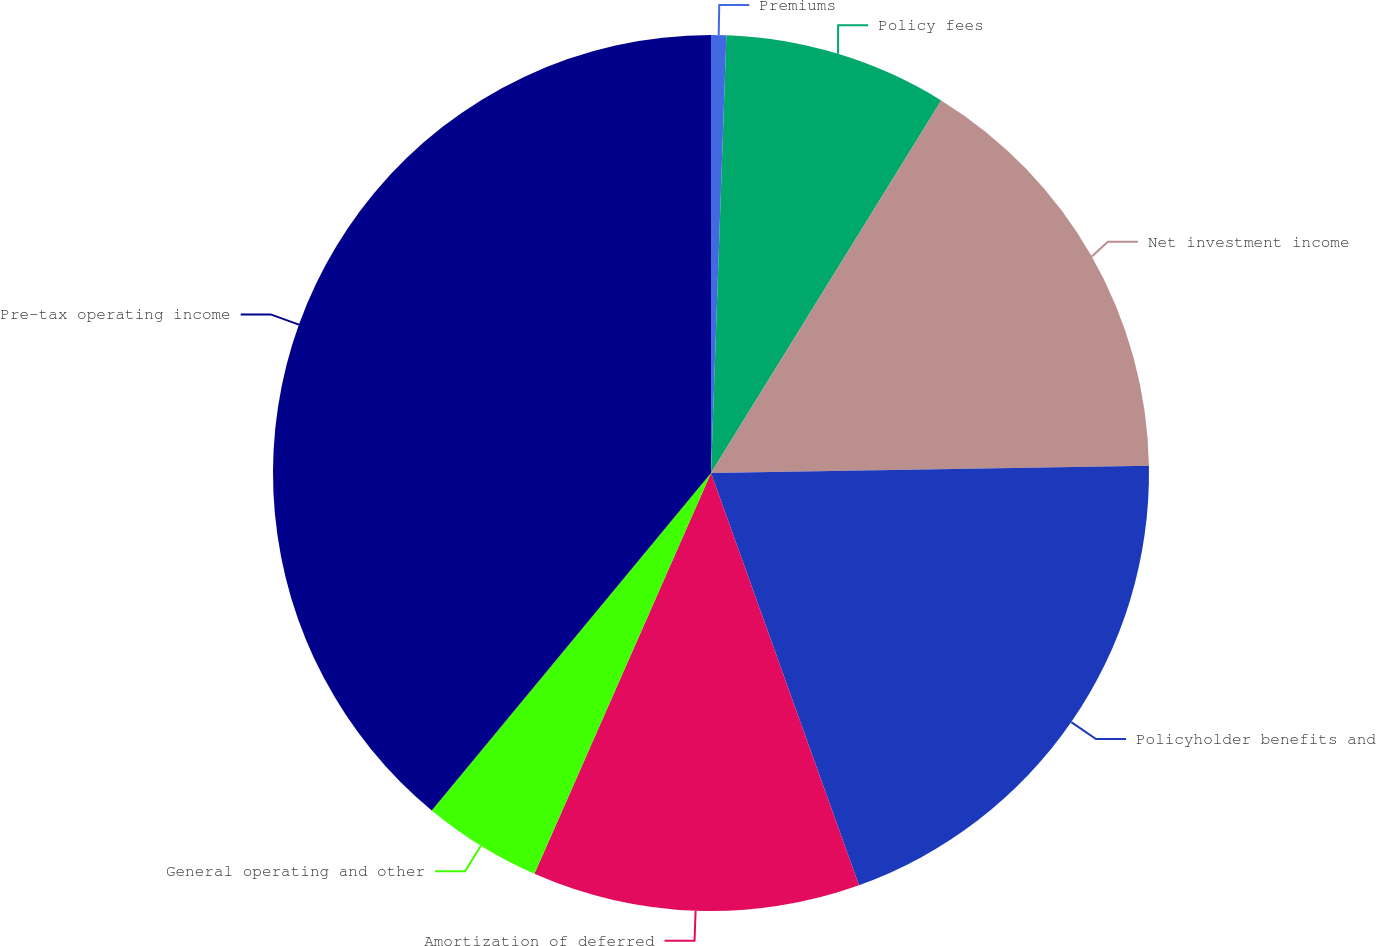Convert chart. <chart><loc_0><loc_0><loc_500><loc_500><pie_chart><fcel>Premiums<fcel>Policy fees<fcel>Net investment income<fcel>Policyholder benefits and<fcel>Amortization of deferred<fcel>General operating and other<fcel>Pre-tax operating income<nl><fcel>0.56%<fcel>8.25%<fcel>15.93%<fcel>19.78%<fcel>12.09%<fcel>4.4%<fcel>39.0%<nl></chart> 